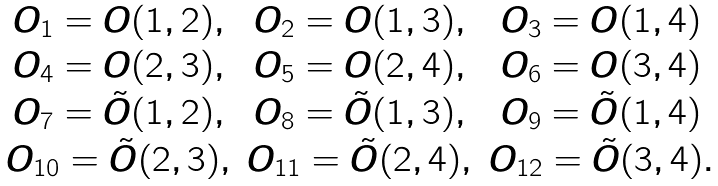<formula> <loc_0><loc_0><loc_500><loc_500>\begin{array} { c c c } O _ { 1 } = O ( 1 , 2 ) , & O _ { 2 } = O ( 1 , 3 ) , & O _ { 3 } = O ( 1 , 4 ) \\ O _ { 4 } = O ( 2 , 3 ) , & O _ { 5 } = O ( 2 , 4 ) , & O _ { 6 } = O ( 3 , 4 ) \\ O _ { 7 } = \tilde { O } ( 1 , 2 ) , & O _ { 8 } = \tilde { O } ( 1 , 3 ) , & O _ { 9 } = \tilde { O } ( 1 , 4 ) \\ O _ { 1 0 } = \tilde { O } ( 2 , 3 ) , & O _ { 1 1 } = \tilde { O } ( 2 , 4 ) , & O _ { 1 2 } = \tilde { O } ( 3 , 4 ) . \end{array}</formula> 